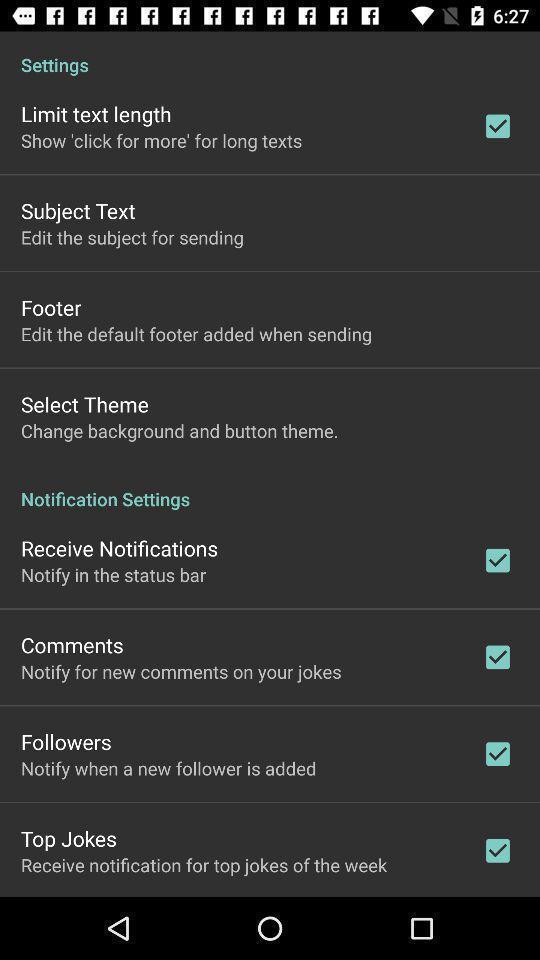Please provide a description for this image. Page showing variety of settings. 